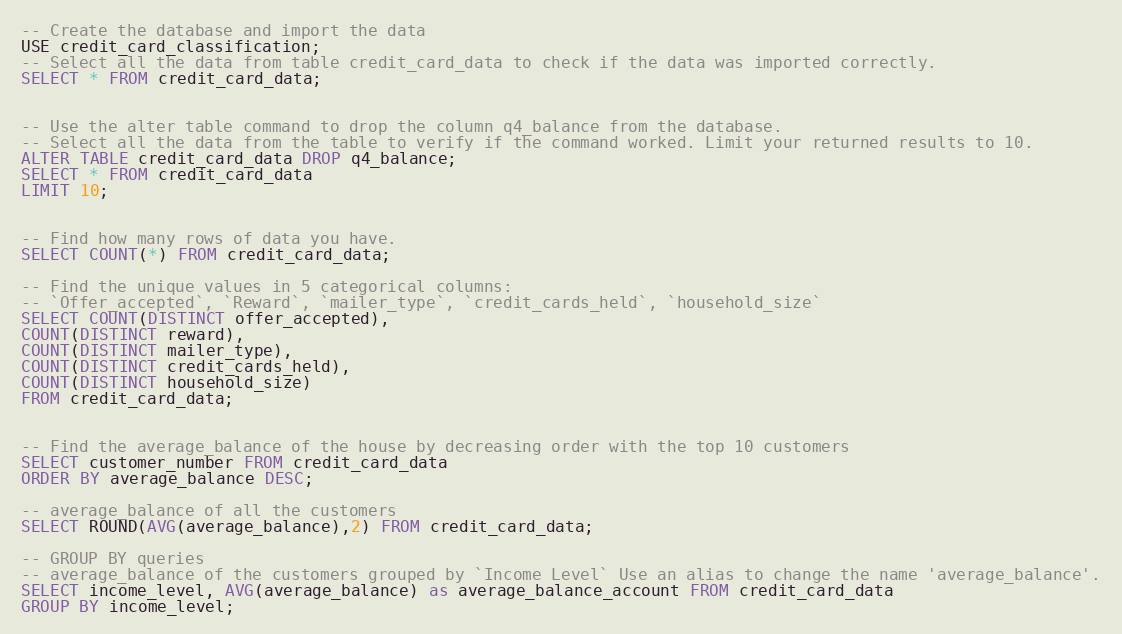Convert code to text. <code><loc_0><loc_0><loc_500><loc_500><_SQL_>-- Create the database and import the data
USE credit_card_classification;
-- Select all the data from table credit_card_data to check if the data was imported correctly.
SELECT * FROM credit_card_data;


-- Use the alter table command to drop the column q4_balance from the database.
-- Select all the data from the table to verify if the command worked. Limit your returned results to 10.
ALTER TABLE credit_card_data DROP q4_balance;
SELECT * FROM credit_card_data
LIMIT 10;


-- Find how many rows of data you have.
SELECT COUNT(*) FROM credit_card_data;

-- Find the unique values in 5 categorical columns:
-- `Offer_accepted`, `Reward`, `mailer_type`, `credit_cards_held`, `household_size`
SELECT COUNT(DISTINCT offer_accepted),
COUNT(DISTINCT reward),
COUNT(DISTINCT mailer_type),
COUNT(DISTINCT credit_cards_held),
COUNT(DISTINCT household_size)
FROM credit_card_data;


-- Find the average_balance of the house by decreasing order with the top 10 customers 
SELECT customer_number FROM credit_card_data
ORDER BY average_balance DESC;

-- average_balance of all the customers
SELECT ROUND(AVG(average_balance),2) FROM credit_card_data;

-- GROUP BY queries
-- average_balance of the customers grouped by `Income Level` Use an alias to change the name 'average_balance'.
SELECT income_level, AVG(average_balance) as average_balance_account FROM credit_card_data
GROUP BY income_level;</code> 